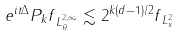<formula> <loc_0><loc_0><loc_500><loc_500>\| e ^ { i t \Delta } P _ { k } f \| _ { L _ { \theta } ^ { 2 , \infty } } \lesssim 2 ^ { k ( d - 1 ) / 2 } \| f \| _ { L _ { x } ^ { 2 } }</formula> 